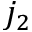Convert formula to latex. <formula><loc_0><loc_0><loc_500><loc_500>j _ { 2 }</formula> 